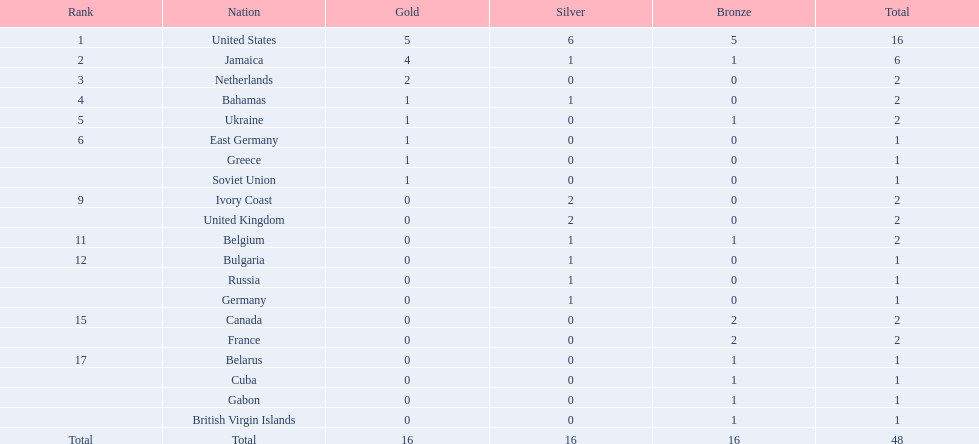Which countries were involved in the competition? United States, Jamaica, Netherlands, Bahamas, Ukraine, East Germany, Greece, Soviet Union, Ivory Coast, United Kingdom, Belgium, Bulgaria, Russia, Germany, Canada, France, Belarus, Cuba, Gabon, British Virgin Islands. How many gold medals did each achieve? 5, 4, 2, 1, 1, 1, 1, 1, 0, 0, 0, 0, 0, 0, 0, 0, 0, 0, 0, 0. And which country had the most gold medal wins? United States. Would you mind parsing the complete table? {'header': ['Rank', 'Nation', 'Gold', 'Silver', 'Bronze', 'Total'], 'rows': [['1', 'United States', '5', '6', '5', '16'], ['2', 'Jamaica', '4', '1', '1', '6'], ['3', 'Netherlands', '2', '0', '0', '2'], ['4', 'Bahamas', '1', '1', '0', '2'], ['5', 'Ukraine', '1', '0', '1', '2'], ['6', 'East Germany', '1', '0', '0', '1'], ['', 'Greece', '1', '0', '0', '1'], ['', 'Soviet Union', '1', '0', '0', '1'], ['9', 'Ivory Coast', '0', '2', '0', '2'], ['', 'United Kingdom', '0', '2', '0', '2'], ['11', 'Belgium', '0', '1', '1', '2'], ['12', 'Bulgaria', '0', '1', '0', '1'], ['', 'Russia', '0', '1', '0', '1'], ['', 'Germany', '0', '1', '0', '1'], ['15', 'Canada', '0', '0', '2', '2'], ['', 'France', '0', '0', '2', '2'], ['17', 'Belarus', '0', '0', '1', '1'], ['', 'Cuba', '0', '0', '1', '1'], ['', 'Gabon', '0', '0', '1', '1'], ['', 'British Virgin Islands', '0', '0', '1', '1'], ['Total', 'Total', '16', '16', '16', '48']]} 